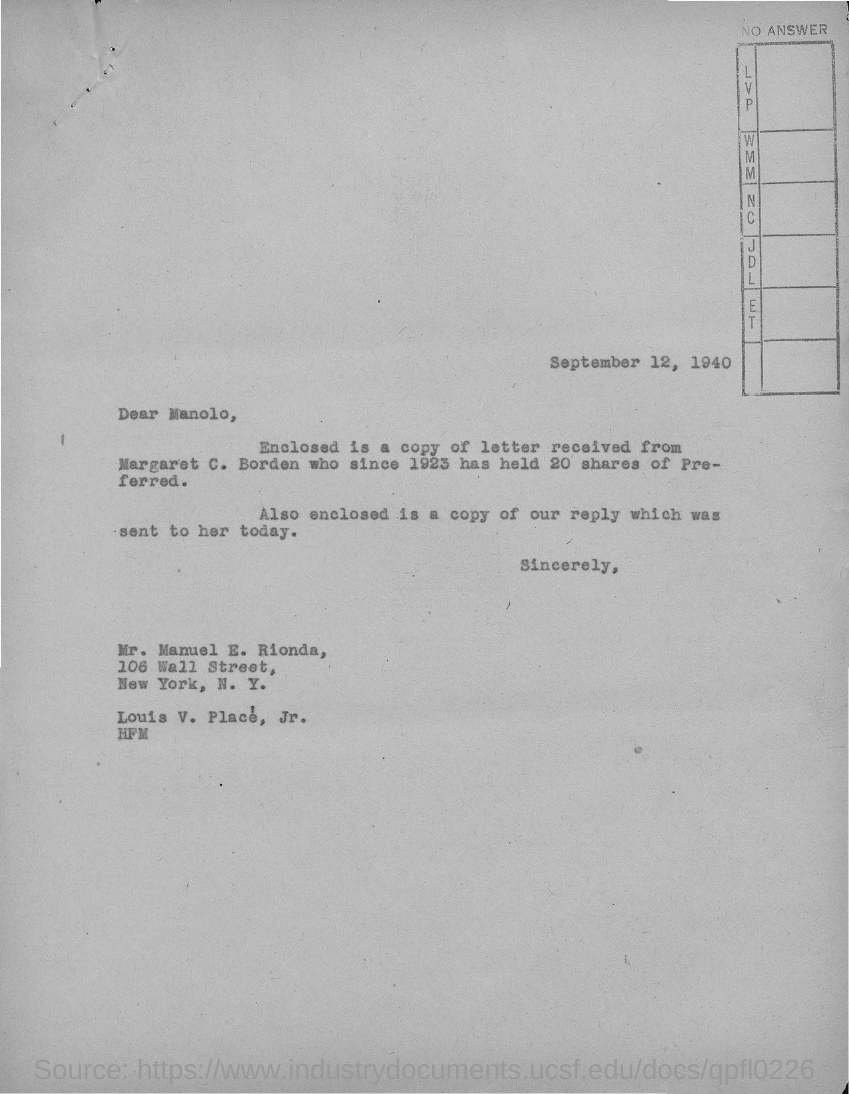What is the date mentioned in this letter?
Make the answer very short. September 12, 1940. Who is the addressee of this letter?
Provide a short and direct response. Manolo. 